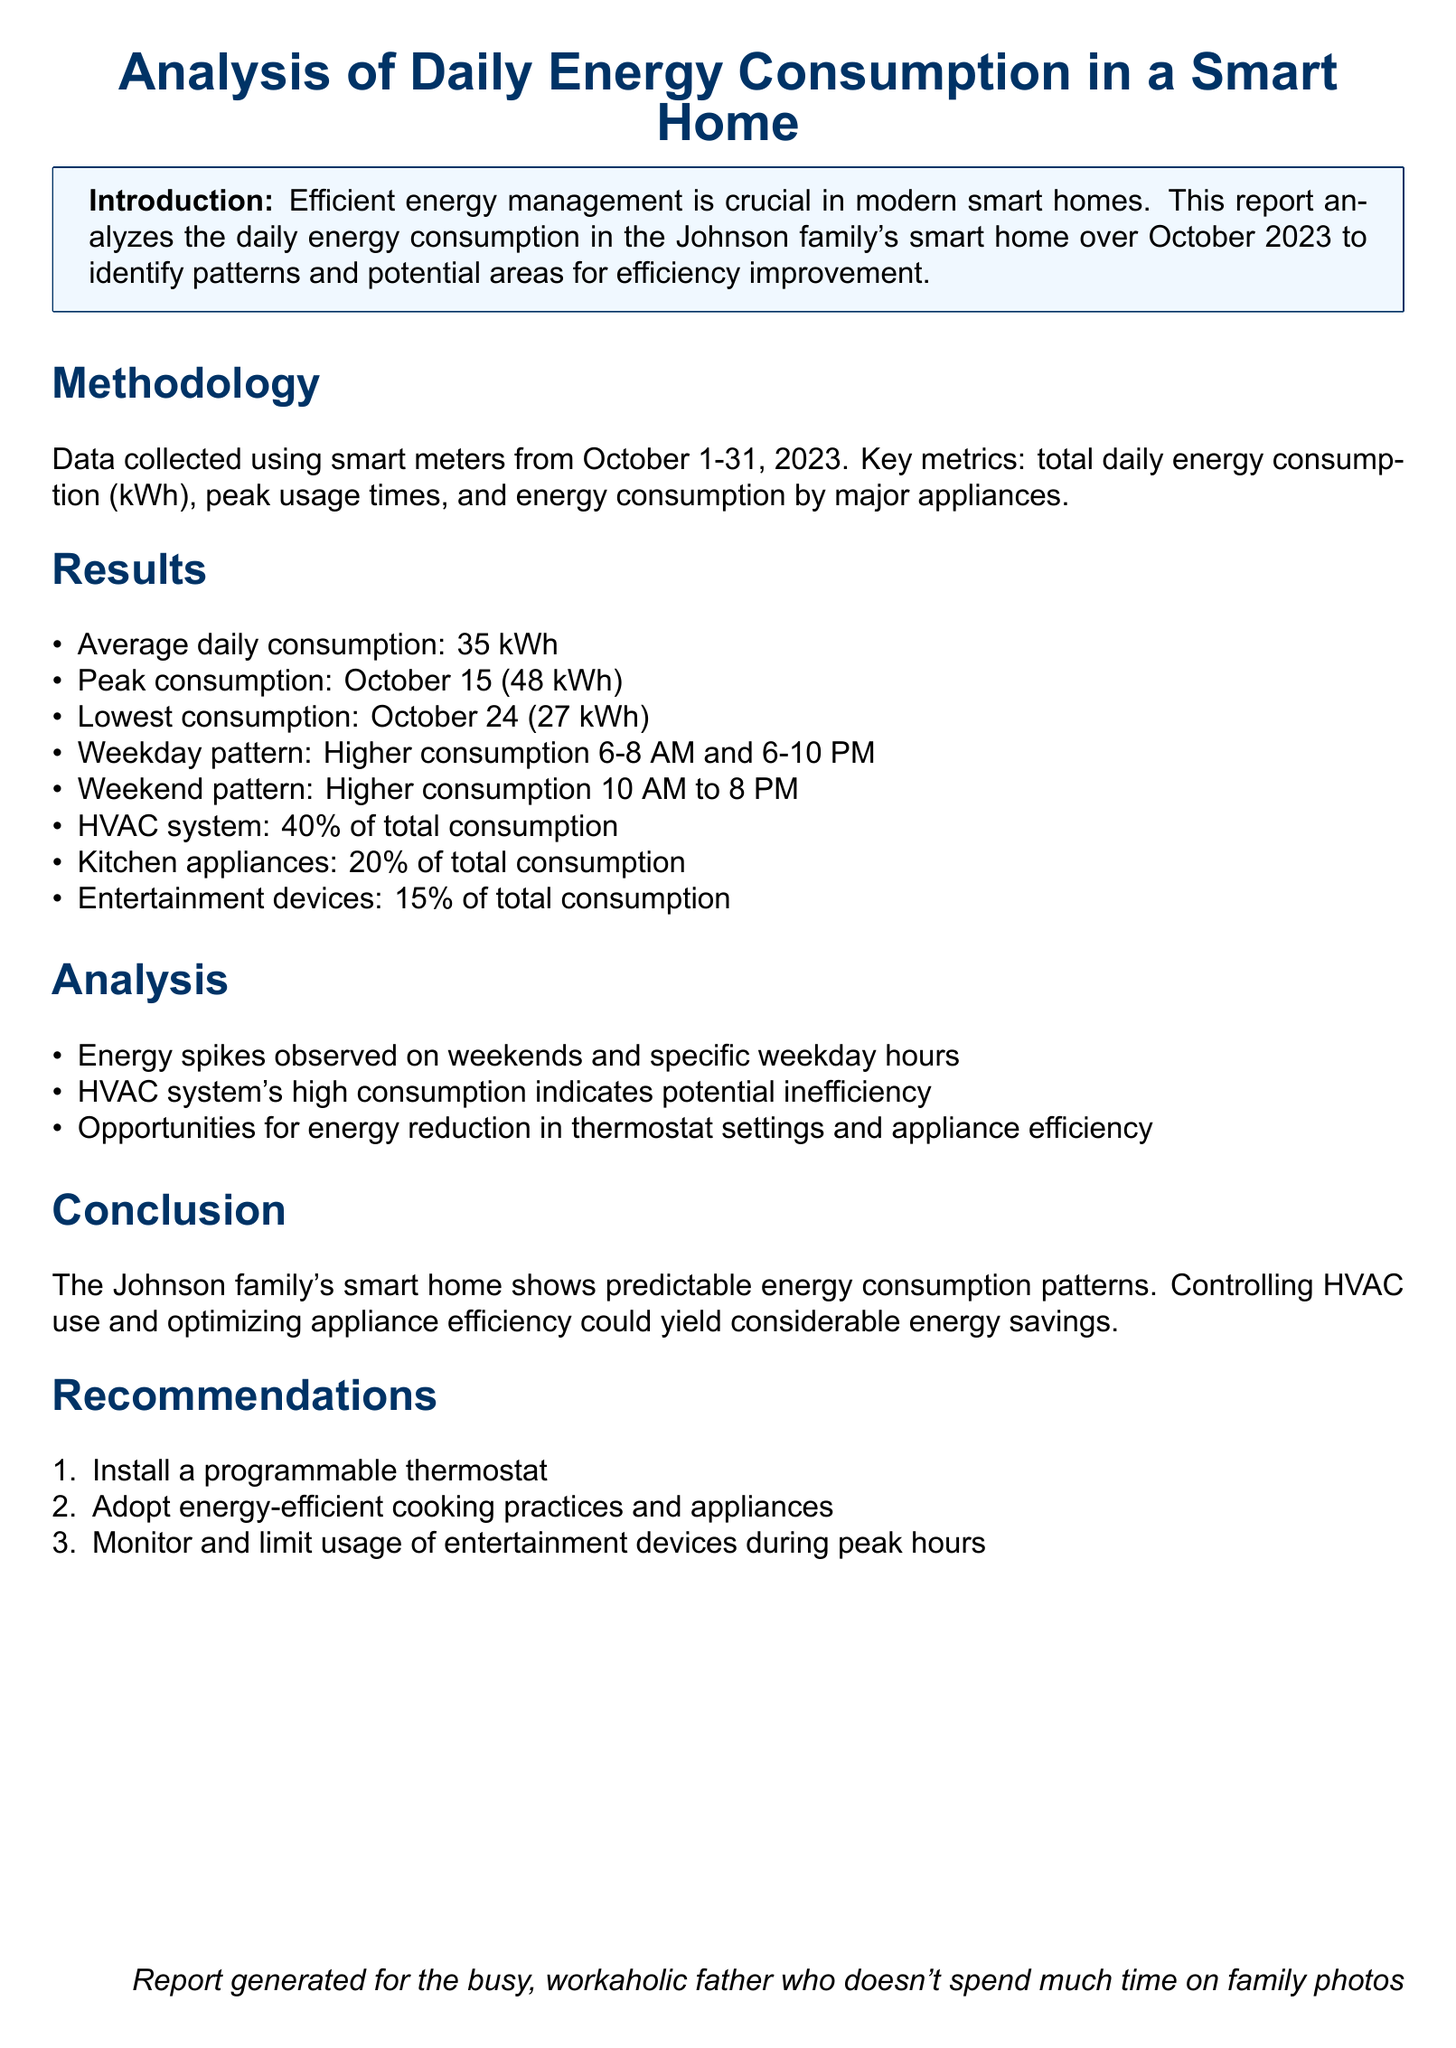What is the average daily energy consumption? The average daily energy consumption is given in the results section, which states that it is 35 kWh.
Answer: 35 kWh When did the peak consumption occur? The peak consumption date is specified in the results section, indicating it occurred on October 15.
Answer: October 15 What percentage of total consumption is attributed to HVAC systems? The percentage attributed to HVAC systems is mentioned in the results section as 40%.
Answer: 40% What is the lowest daily consumption recorded? The lowest daily consumption is provided in the results section, which shows it was 27 kWh on October 24.
Answer: 27 kWh What time frame is identified for higher energy consumption on weekdays? The time frame for higher energy consumption on weekdays is detailed in the results section as between 6-8 AM and 6-10 PM.
Answer: 6-8 AM and 6-10 PM Which appliances account for 20% of total consumption? Kitchen appliances are outlined in the results section as accounting for 20% of total consumption.
Answer: Kitchen appliances What is one potential recommendation provided? The recommendation section includes several suggestions, one of which is to install a programmable thermostat.
Answer: Install a programmable thermostat What was the main focus of the analysis section? The analysis section emphasizes observing energy spikes and HVAC inefficiency as the main focus.
Answer: Energy spikes and HVAC inefficiency What is the main conclusion drawn from the report? The conclusion drawn from the report indicates that controlling HVAC use could yield energy savings.
Answer: Controlling HVAC use could yield energy savings 